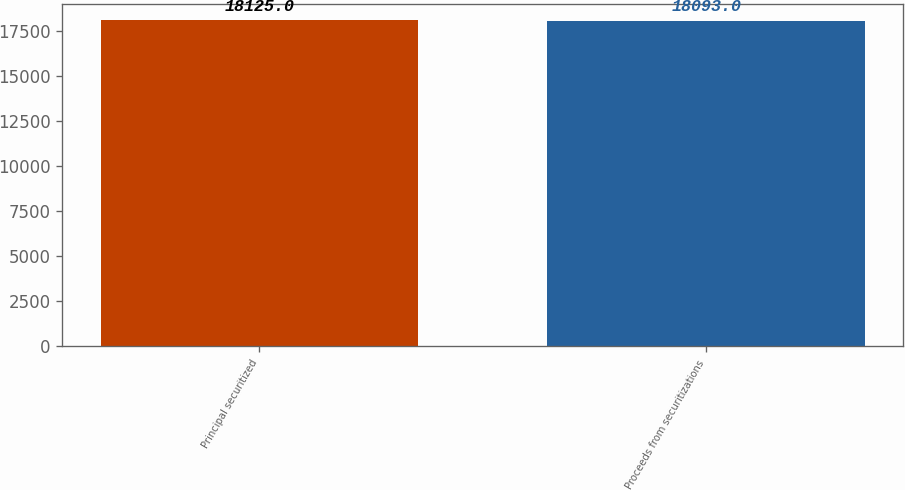<chart> <loc_0><loc_0><loc_500><loc_500><bar_chart><fcel>Principal securitized<fcel>Proceeds from securitizations<nl><fcel>18125<fcel>18093<nl></chart> 